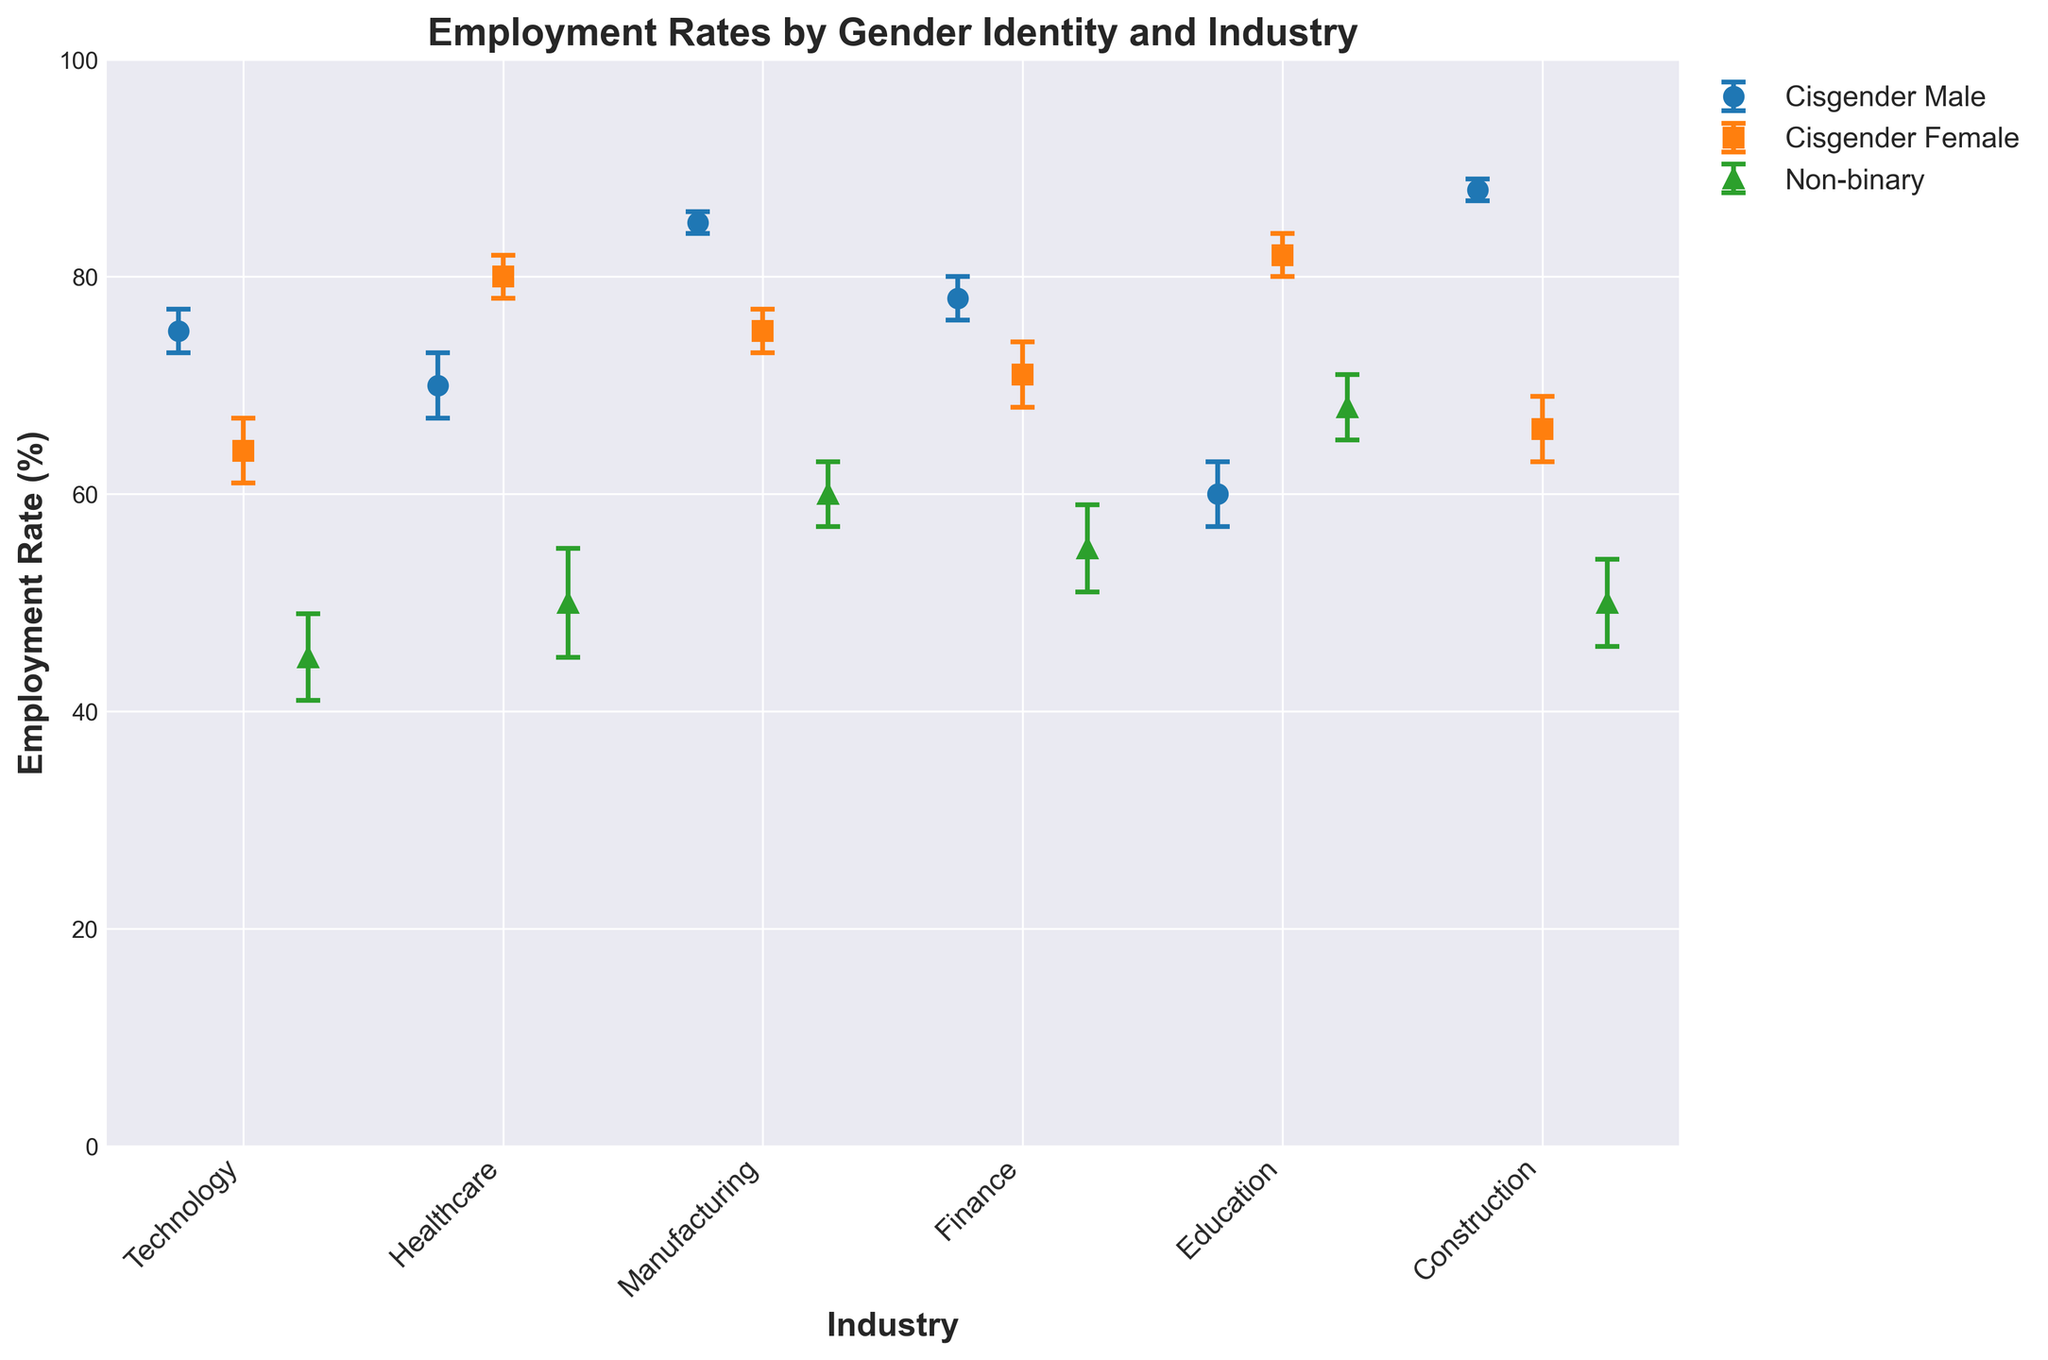What is the title of the plot? The title of the plot is displayed at the top and reads "Employment Rates by Gender Identity and Industry".
Answer: Employment Rates by Gender Identity and Industry Which industry has the highest employment rate for Cisgender Males? To find the highest employment rate for Cisgender Males, look at the highest dot in blue color with a circle marker. The highest dot for Cisgender Males is in the Construction industry in Asia, with an employment rate of 88%.
Answer: Construction What is the employment rate difference between Non-binary individuals and Cisgender Females in the Healthcare industry in Europe? The employment rate for Non-binary individuals in Healthcare is 50%, and for Cisgender Females, it is 80%. Subtract the two to find the difference. 80 - 50 = 30.
Answer: 30% Which gender identity group has the smallest error margin across all industries? The error margin is represented by the length of the error bars. The shortest error bar across all industries is for Cisgender Males in the Manufacturing and Construction industries, with an error of 1.
Answer: Cisgender Males Compared to Cisgender Females in the Finance industry, how much lower is the employment rate for Non-binary individuals in the same industry? The employment rate for Cisgender Females in Finance is 71%, while for Non-binary individuals, it is 55%. Subtract these values to find the difference: 71 - 55 = 16.
Answer: 16% Which industry in North America has the highest employment rate for Cisgender Females? Look at the orange-colored squares in North America. The highest employment rate for Cisgender Females in North America is in the Finance industry, with a rate of 71%.
Answer: Finance What is the average employment rate for Non-binary individuals across all industries? To find the average, add up the employment rates for Non-binary individuals across all industries and divide by the number of industries. (45 + 50 + 60 + 55 + 68 + 50) / 6 = 328 / 6 ≈ 54.67.
Answer: 54.67% Which industry in Europe shows the largest gender identity employment rate disparity? To determine the largest disparity, look for the greatest difference between the highest and lowest employment rates among gender identities in European industries. In the Education industry in Europe, the disparity is 82% (Cisgender Females) - 60% (Cisgender Males) = 22%.
Answer: Education In which industry and region do Cisgender Females have a higher employment rate than Cisgender Males? Look for industries where the orange-colored squares (Cisgender Females) are higher than the blue-colored circles (Cisgender Males). In Healthcare in Europe, Cisgender Females have an employment rate of 80%, while Cisgender Males have 70%. Similarly, in Education in Europe, Cisgender Females have 82%, while Cisgender Males have 60%.
Answer: Healthcare in Europe and Education in Europe 